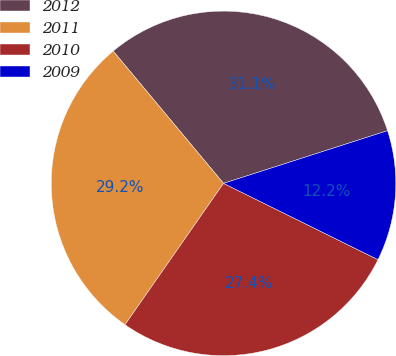Convert chart. <chart><loc_0><loc_0><loc_500><loc_500><pie_chart><fcel>2012<fcel>2011<fcel>2010<fcel>2009<nl><fcel>31.12%<fcel>29.25%<fcel>27.39%<fcel>12.25%<nl></chart> 